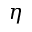<formula> <loc_0><loc_0><loc_500><loc_500>\eta</formula> 